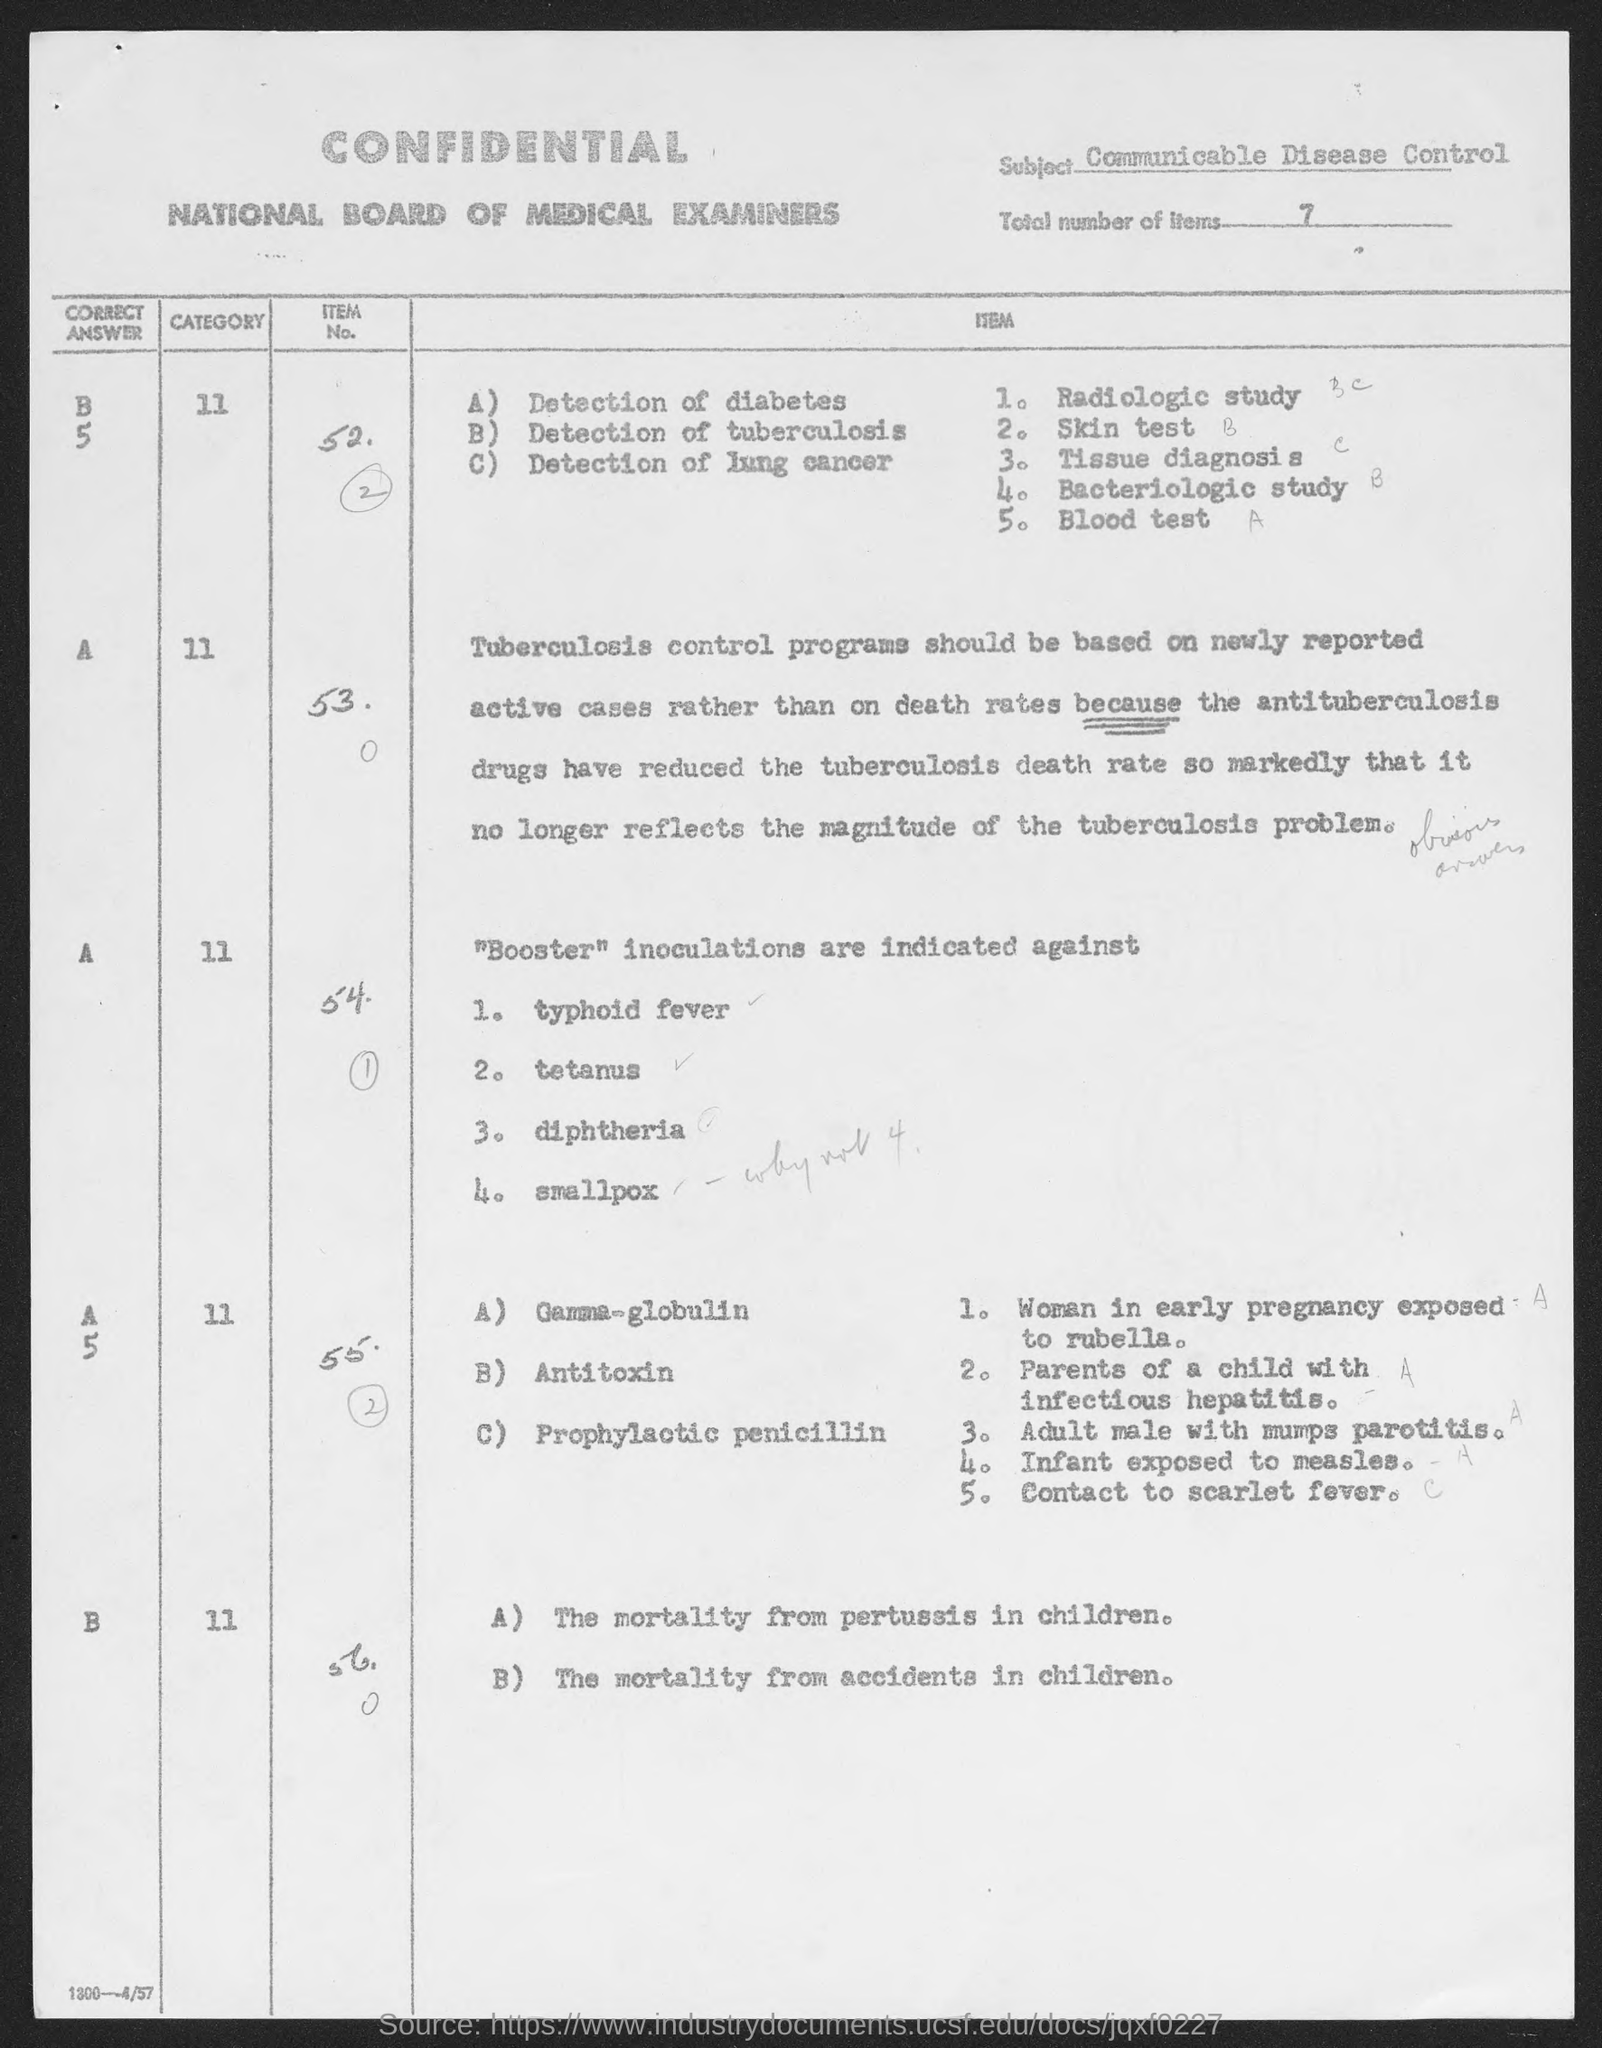Outline some significant characteristics in this image. Communicable Disease Control is the subject of inquiry. The total number of items is 7. 